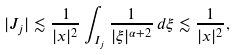<formula> <loc_0><loc_0><loc_500><loc_500>| J _ { j } | \lesssim \frac { 1 } { | x | ^ { 2 } } \int _ { I _ { j } } \frac { 1 } { | \xi | ^ { \alpha + 2 } } \, d \xi \lesssim \frac { 1 } { | x | ^ { 2 } } ,</formula> 